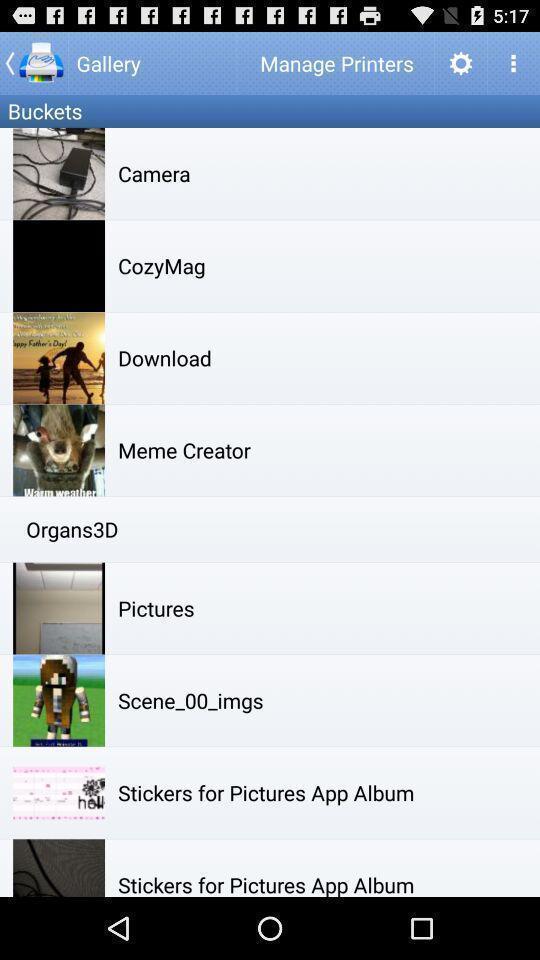Describe the visual elements of this screenshot. Page showing various images for mobile printing app. 